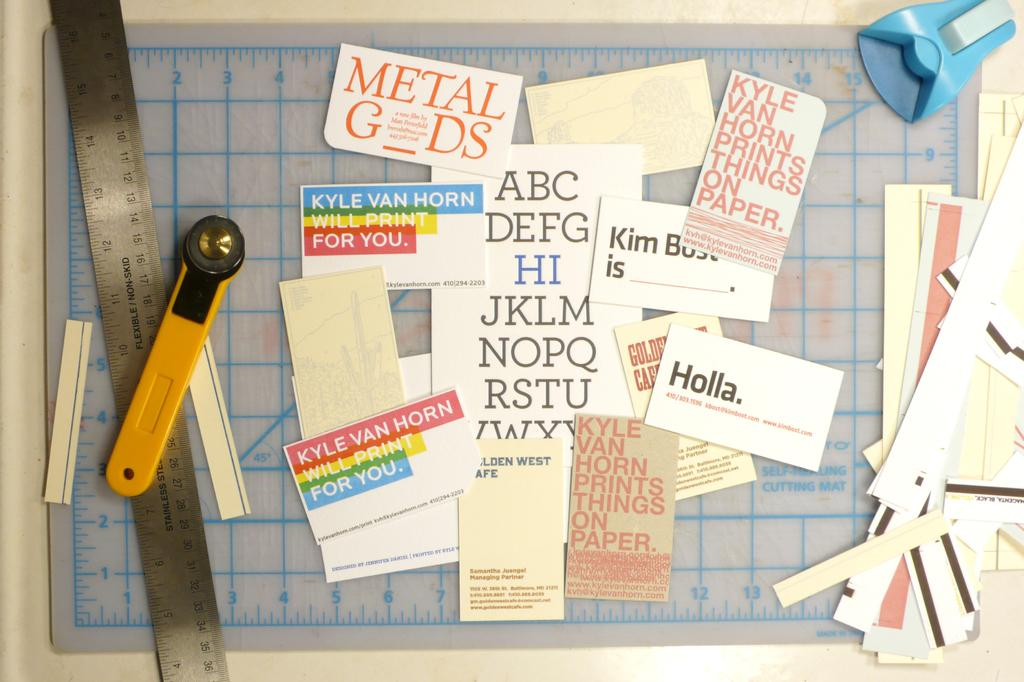<image>
Relay a brief, clear account of the picture shown. A measuring stick and other scrap booking tools with phrases cut out of magazines showing the alphabet, holla, and other phrases. 